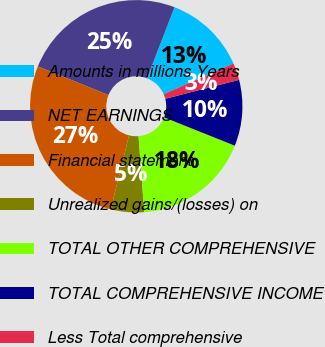Convert chart. <chart><loc_0><loc_0><loc_500><loc_500><pie_chart><fcel>Amounts in millions Years<fcel>NET EARNINGS<fcel>Financial statement<fcel>Unrealized gains/(losses) on<fcel>TOTAL OTHER COMPREHENSIVE<fcel>TOTAL COMPREHENSIVE INCOME<fcel>Less Total comprehensive<nl><fcel>12.55%<fcel>24.76%<fcel>27.25%<fcel>5.07%<fcel>17.74%<fcel>10.06%<fcel>2.58%<nl></chart> 